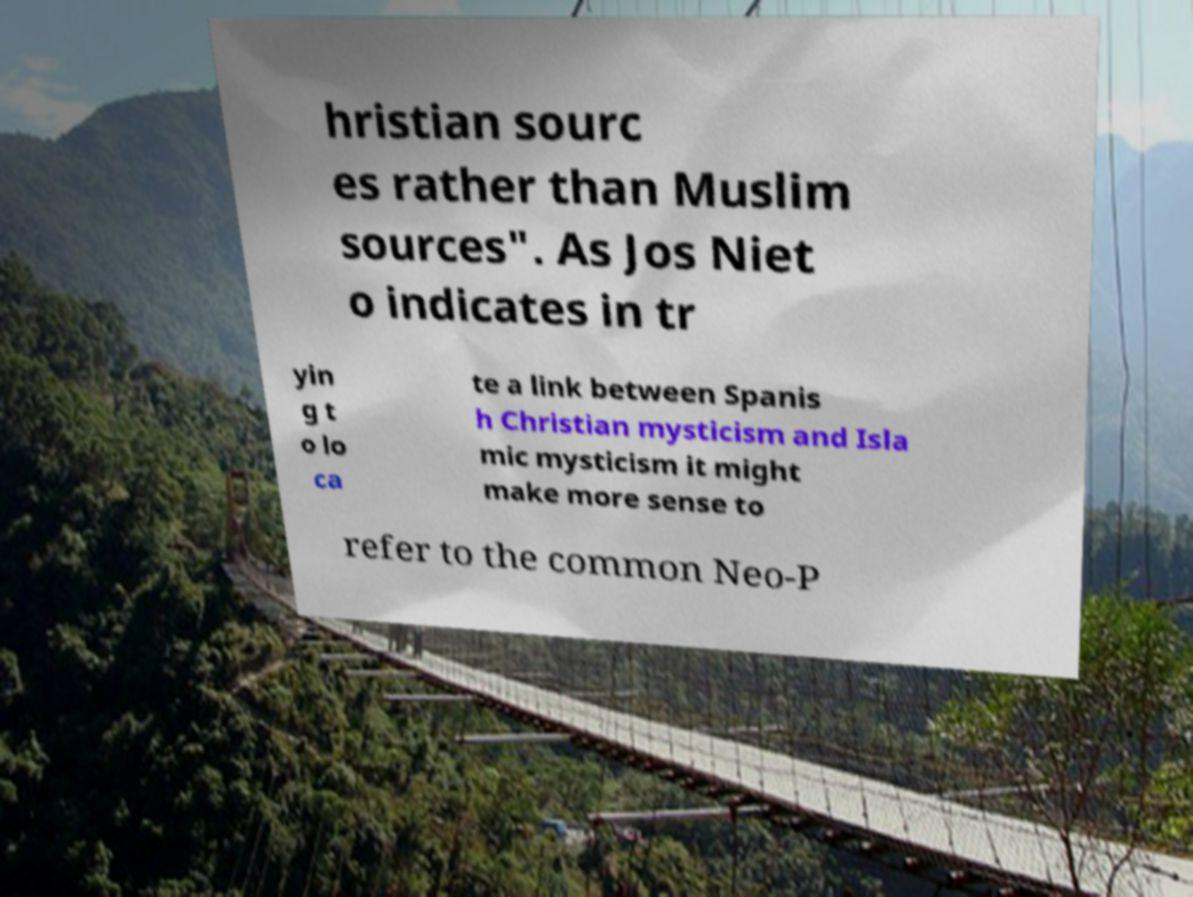Please read and relay the text visible in this image. What does it say? hristian sourc es rather than Muslim sources". As Jos Niet o indicates in tr yin g t o lo ca te a link between Spanis h Christian mysticism and Isla mic mysticism it might make more sense to refer to the common Neo-P 